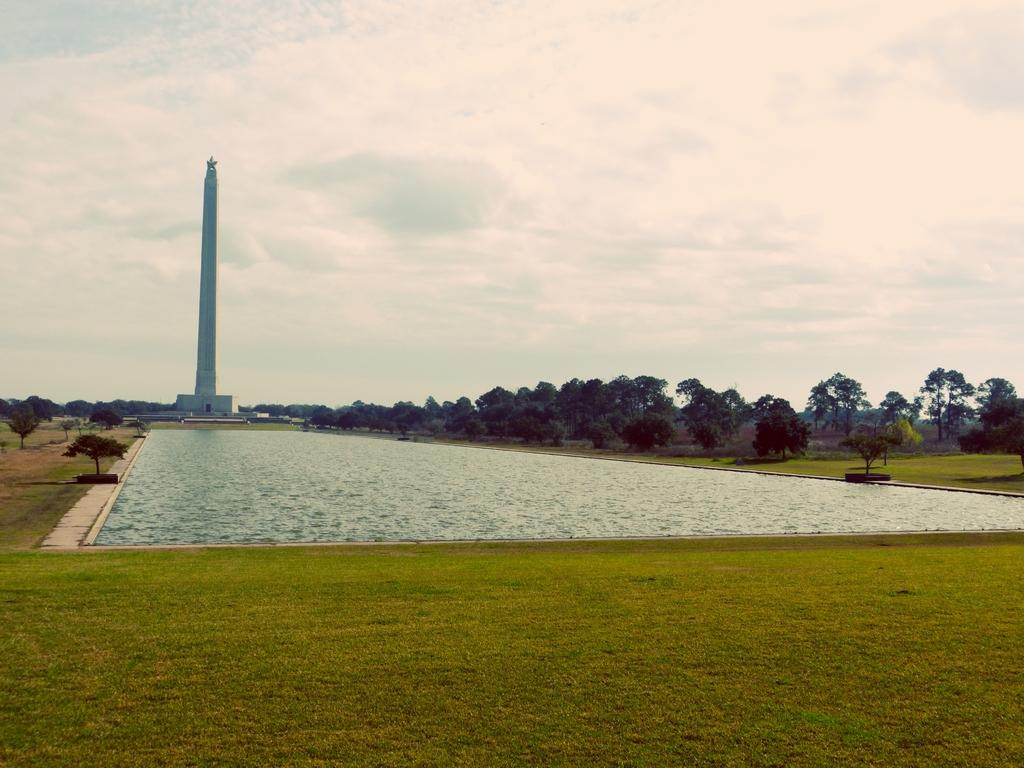What type of vegetation is present in the image? There is grass in the image. What else can be seen in the image besides grass? There is water in the image, as well as trees on both sides of the water. What can be seen in the background of the image? There is a tower visible in the background, along with clouds and the sky. What type of vegetable is growing near the tower in the image? There is no vegetable growing near the tower in the image; the vegetation present is grass. 